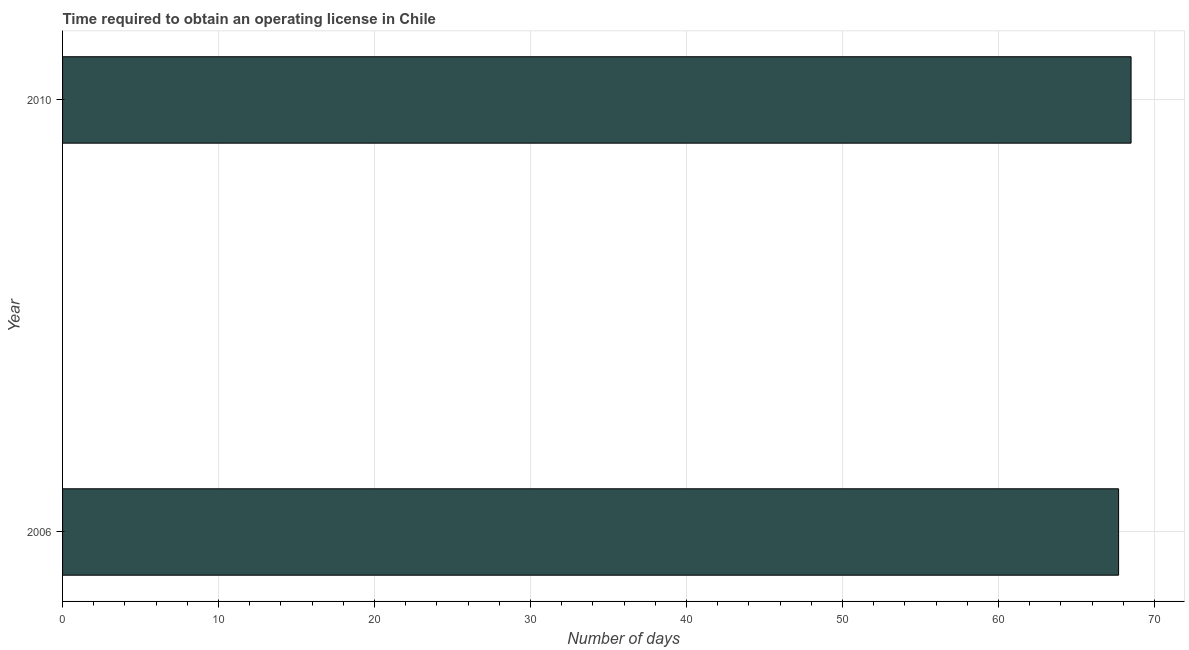Does the graph contain any zero values?
Provide a short and direct response. No. Does the graph contain grids?
Offer a terse response. Yes. What is the title of the graph?
Your answer should be compact. Time required to obtain an operating license in Chile. What is the label or title of the X-axis?
Your response must be concise. Number of days. What is the number of days to obtain operating license in 2010?
Ensure brevity in your answer.  68.5. Across all years, what is the maximum number of days to obtain operating license?
Offer a very short reply. 68.5. Across all years, what is the minimum number of days to obtain operating license?
Give a very brief answer. 67.7. In which year was the number of days to obtain operating license maximum?
Your answer should be compact. 2010. In which year was the number of days to obtain operating license minimum?
Your answer should be very brief. 2006. What is the sum of the number of days to obtain operating license?
Make the answer very short. 136.2. What is the difference between the number of days to obtain operating license in 2006 and 2010?
Provide a short and direct response. -0.8. What is the average number of days to obtain operating license per year?
Make the answer very short. 68.1. What is the median number of days to obtain operating license?
Give a very brief answer. 68.1. Do a majority of the years between 2006 and 2010 (inclusive) have number of days to obtain operating license greater than 12 days?
Offer a very short reply. Yes. What is the ratio of the number of days to obtain operating license in 2006 to that in 2010?
Your response must be concise. 0.99. In how many years, is the number of days to obtain operating license greater than the average number of days to obtain operating license taken over all years?
Offer a terse response. 1. How many years are there in the graph?
Your response must be concise. 2. Are the values on the major ticks of X-axis written in scientific E-notation?
Give a very brief answer. No. What is the Number of days of 2006?
Your answer should be compact. 67.7. What is the Number of days of 2010?
Provide a succinct answer. 68.5. 